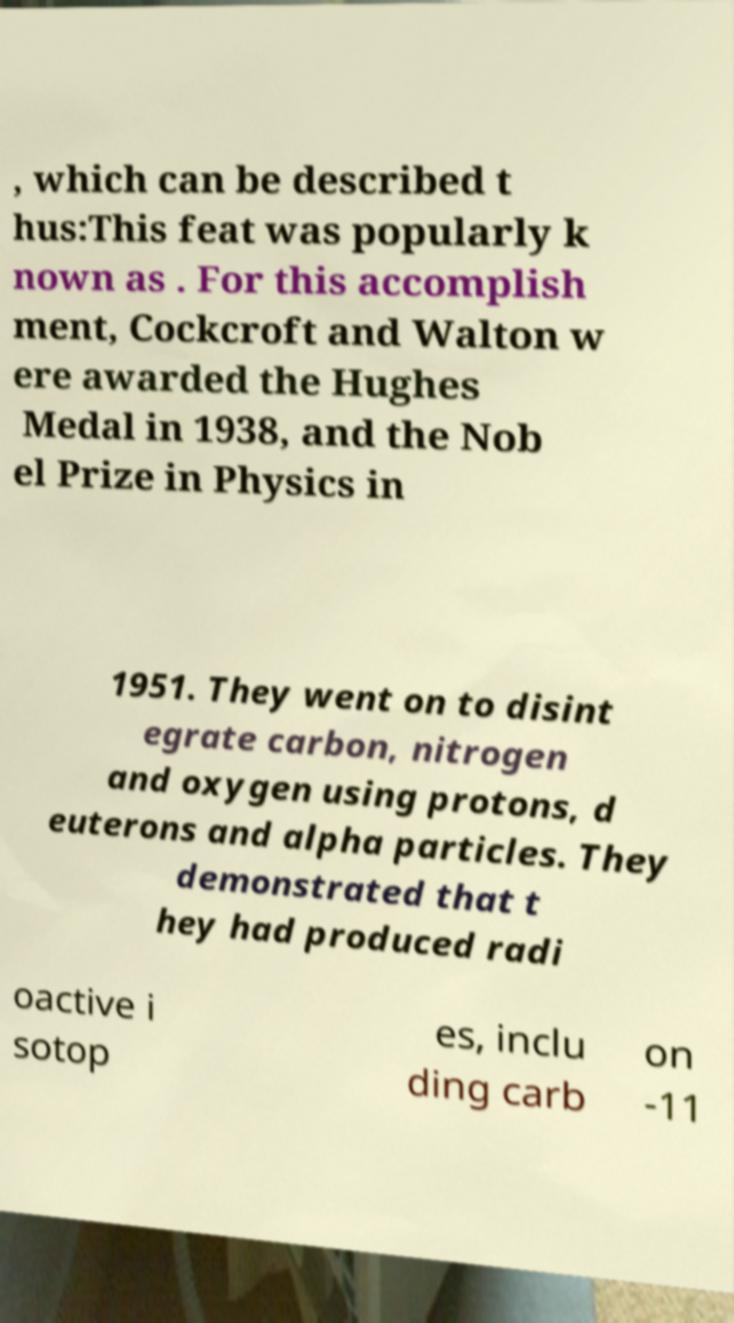Can you read and provide the text displayed in the image?This photo seems to have some interesting text. Can you extract and type it out for me? , which can be described t hus:This feat was popularly k nown as . For this accomplish ment, Cockcroft and Walton w ere awarded the Hughes Medal in 1938, and the Nob el Prize in Physics in 1951. They went on to disint egrate carbon, nitrogen and oxygen using protons, d euterons and alpha particles. They demonstrated that t hey had produced radi oactive i sotop es, inclu ding carb on -11 